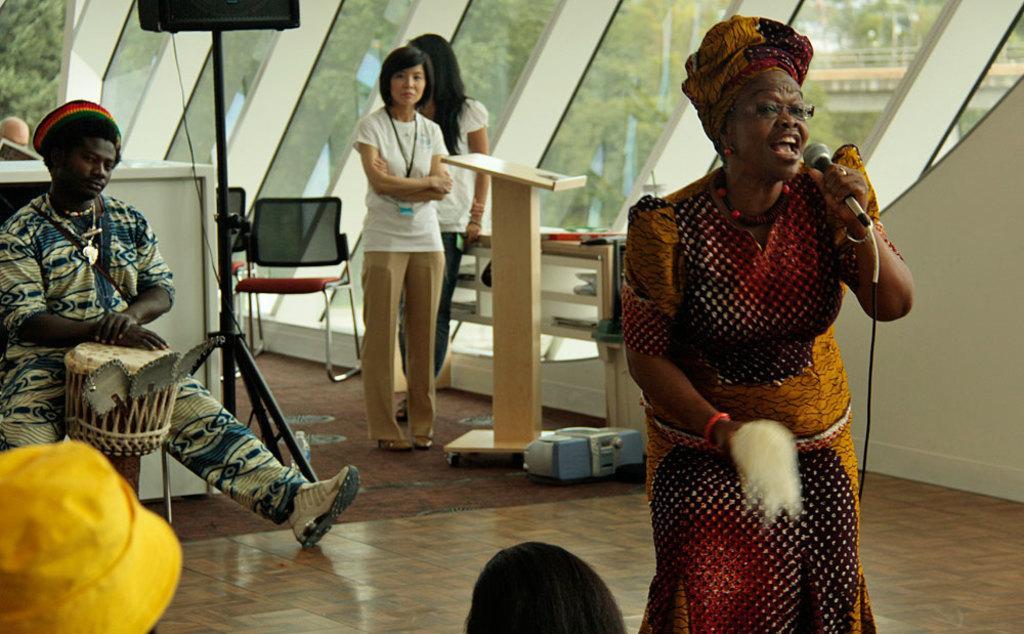Describe this image in one or two sentences. In this picture, we can see a few people and some are holding some objects and we can see the podium, desk, chair, stand and we can see floor, wall with glass and we can see some trees and a bridge from that glass. 